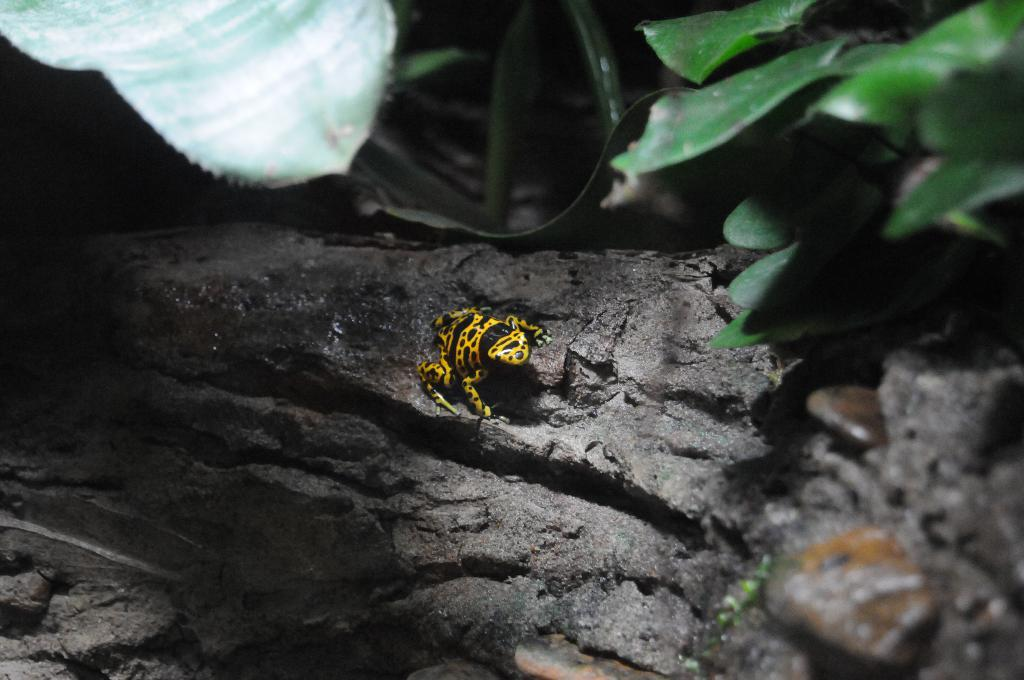What type of animal is in the image? There is a frog in the image. What colors can be seen on the frog? The frog is black and yellow in color. Where is the frog located in the image? The frog is on the bark of a tree. What can be seen in the background of the image? There are plants visible in the background of the image. What type of car can be seen in the image? There is no car present in the image; it features a frog on the bark of a tree. What color is the sock on the frog's foot in the image? There is no sock present on the frog's foot in the image, as frogs do not wear socks. 